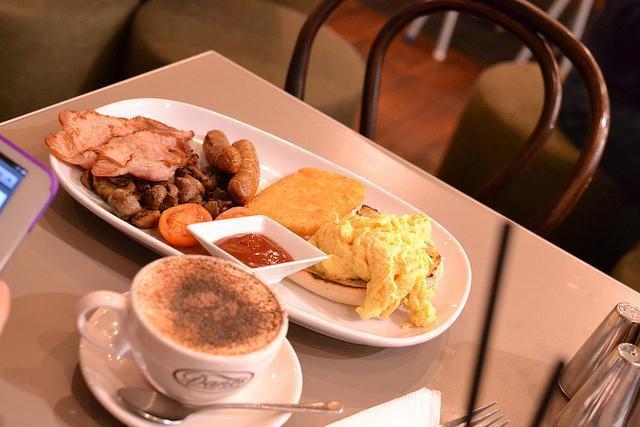How many cell phones are in the picture?
Give a very brief answer. 1. How many cups are there?
Give a very brief answer. 1. 